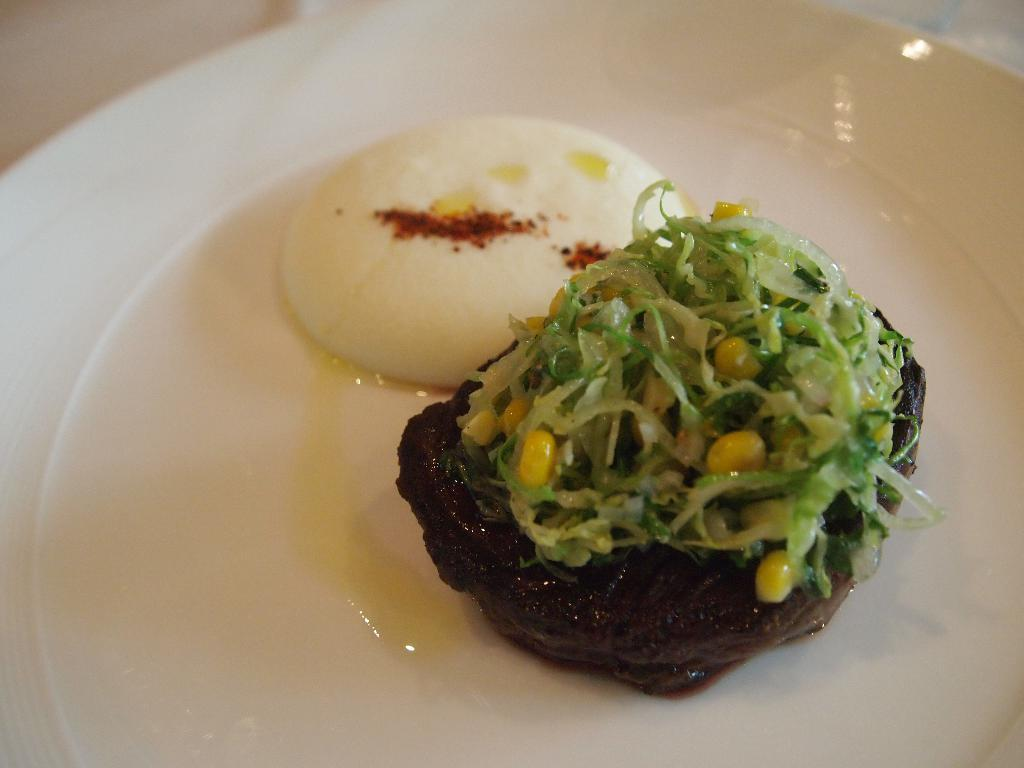What is present on the plate in the image? There are food items placed in the plate. Can you describe the food items on the plate? Unfortunately, the specific food items cannot be determined from the provided facts. What might be the purpose of the plate in the image? The plate is likely being used to hold or serve the food items. What type of disgusting bubble can be seen in the image? There is no bubble present in the image, let alone a disgusting one. 